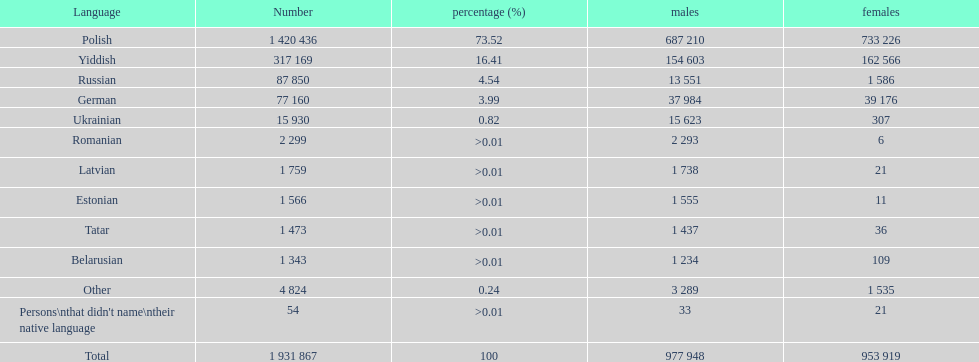Number of male russian speakers 13 551. 